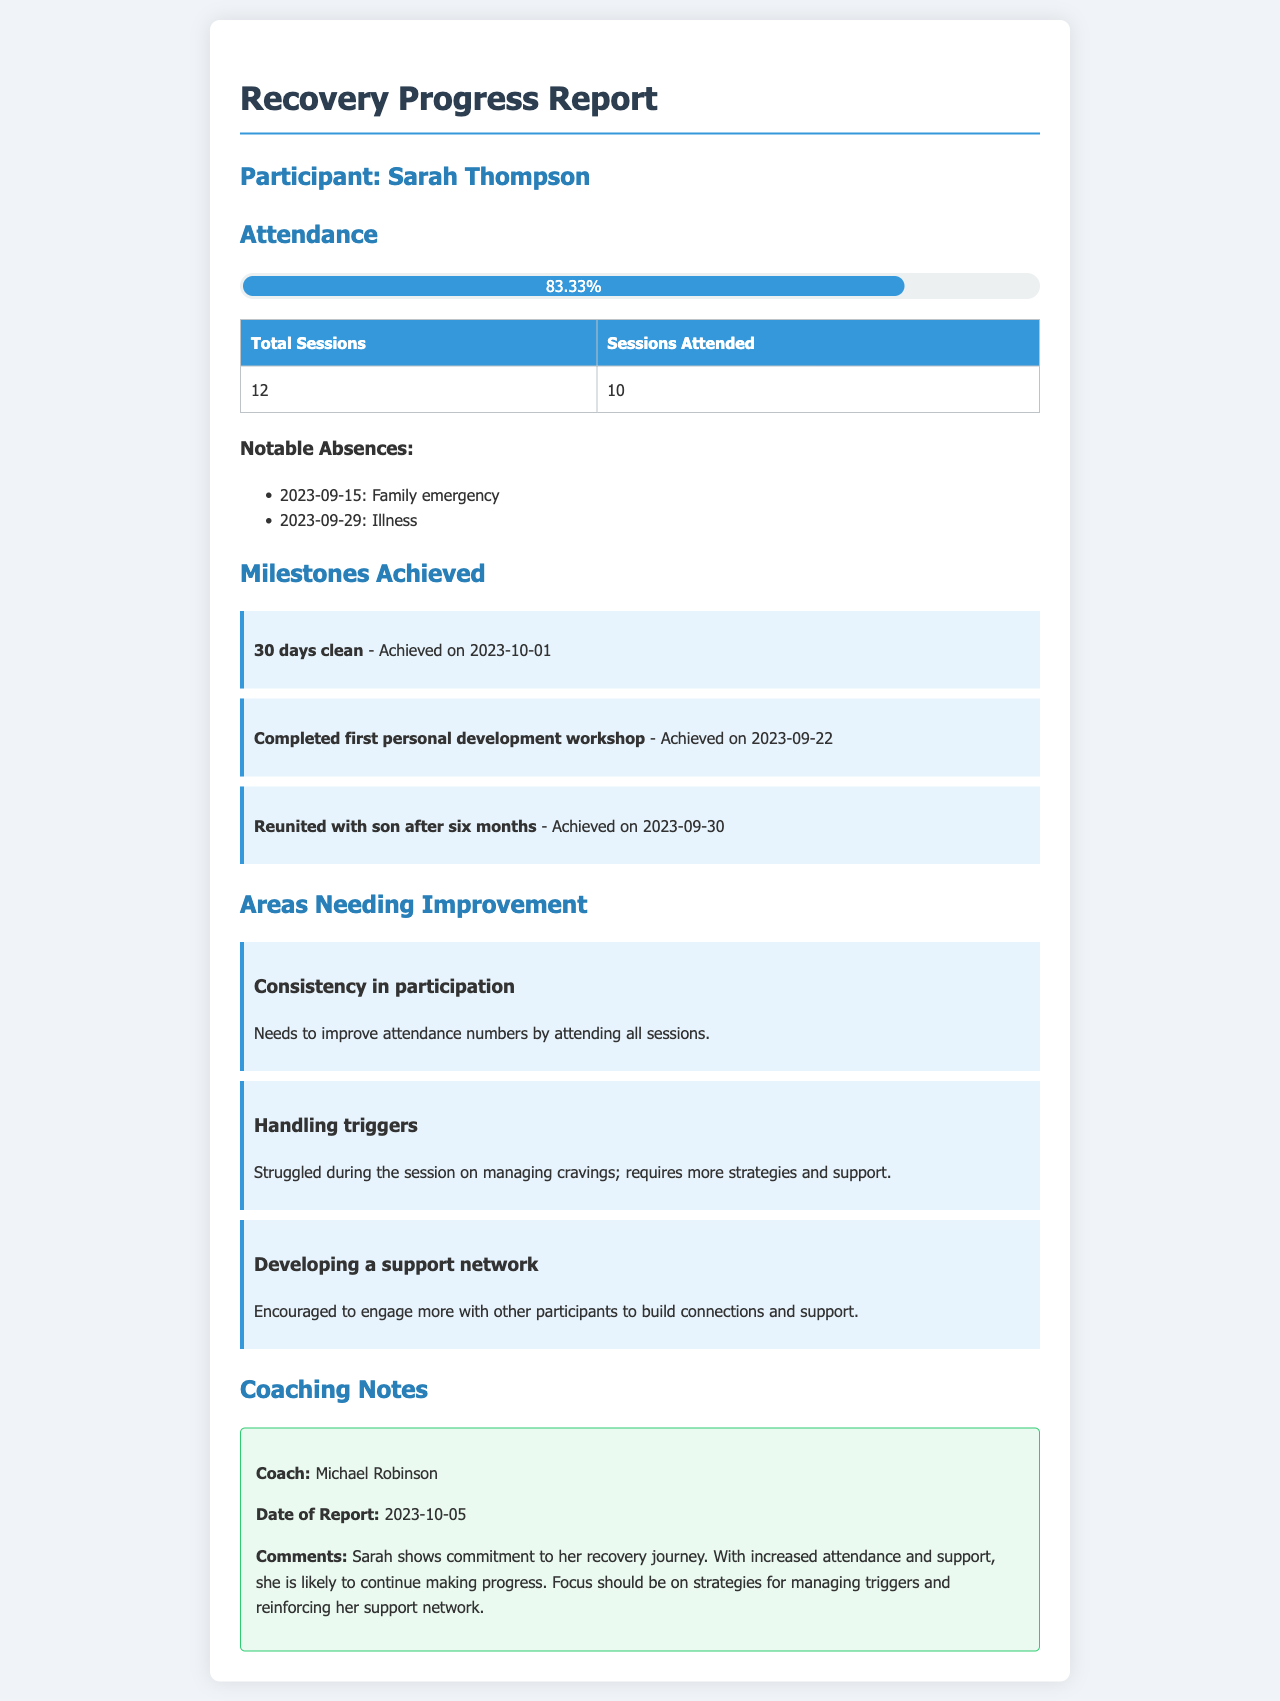What is the participant's name? The participant's name is clearly stated at the beginning of the document under "Participant."
Answer: Sarah Thompson What percentage of sessions did Sarah attend? The percentage is provided in the attendance section under the progress bar, indicating the proportion of sessions attended.
Answer: 83.33% On what date did Sarah achieve 30 days clean? The date is mentioned with the milestone achievement related to being clean for 30 days.
Answer: 2023-10-01 What area needs improvement related to attendance? The area requiring improvement is specified in the "Areas Needing Improvement" section regarding attendance.
Answer: Consistency in participation What significant family event occurred on 2023-09-30? The milestone section mentions an event as significant which corresponds to reconnections with family.
Answer: Reunited with son after six months Who wrote the coaching notes? The section on coaching notes identifies the individual responsible for the report.
Answer: Michael Robinson How many total sessions were scheduled? The total number of sessions is provided in the attendance table.
Answer: 12 What is one strategy Sarah struggled with during the session? The improvement section points out a specific strategy Sarah needs help with regarding cravings.
Answer: Handling triggers 